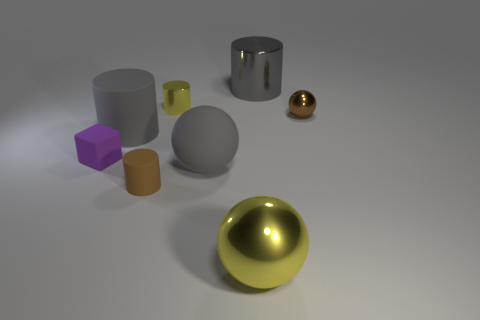Add 1 small gray metal things. How many objects exist? 9 Subtract all blocks. How many objects are left? 7 Subtract all small blue shiny blocks. Subtract all purple cubes. How many objects are left? 7 Add 4 small metal objects. How many small metal objects are left? 6 Add 2 yellow cylinders. How many yellow cylinders exist? 3 Subtract 0 green cylinders. How many objects are left? 8 